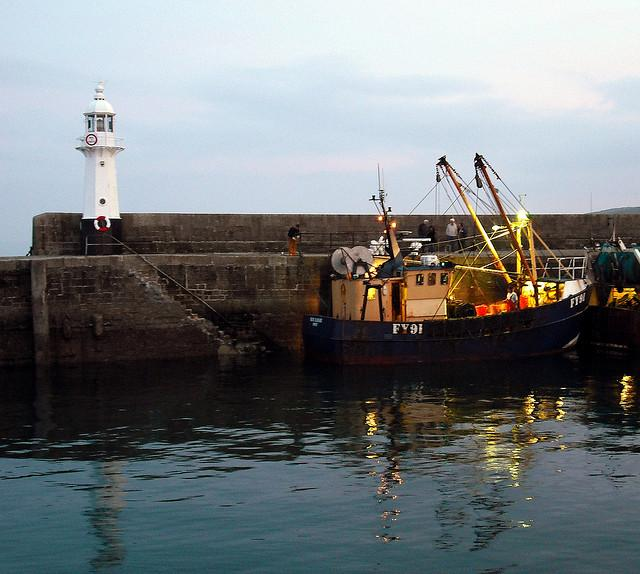When it is dark at night what will the boats use as navigation? lighthouse 